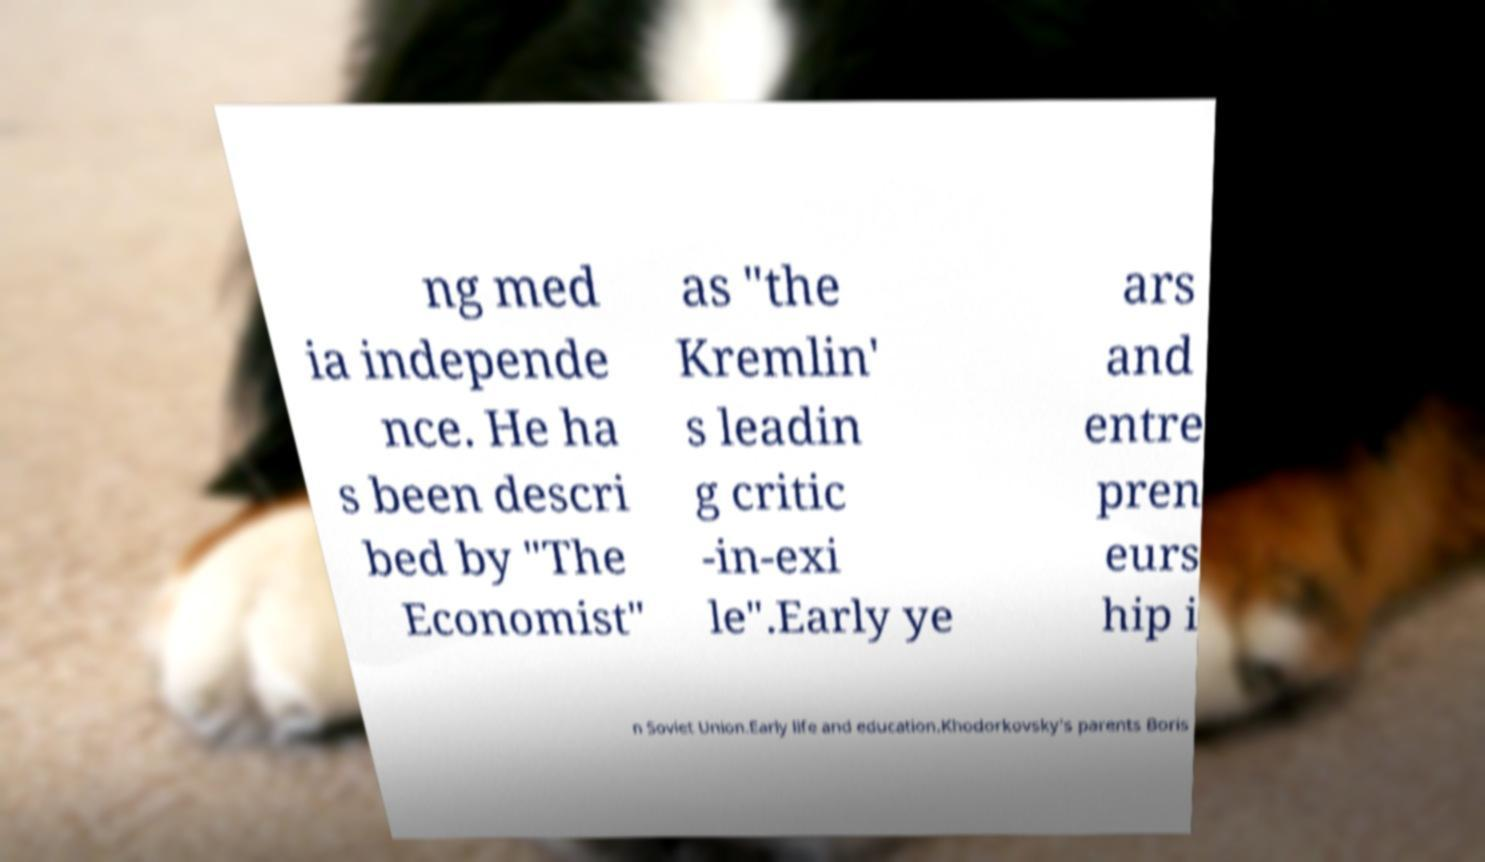What messages or text are displayed in this image? I need them in a readable, typed format. ng med ia independe nce. He ha s been descri bed by "The Economist" as "the Kremlin' s leadin g critic -in-exi le".Early ye ars and entre pren eurs hip i n Soviet Union.Early life and education.Khodorkovsky's parents Boris 